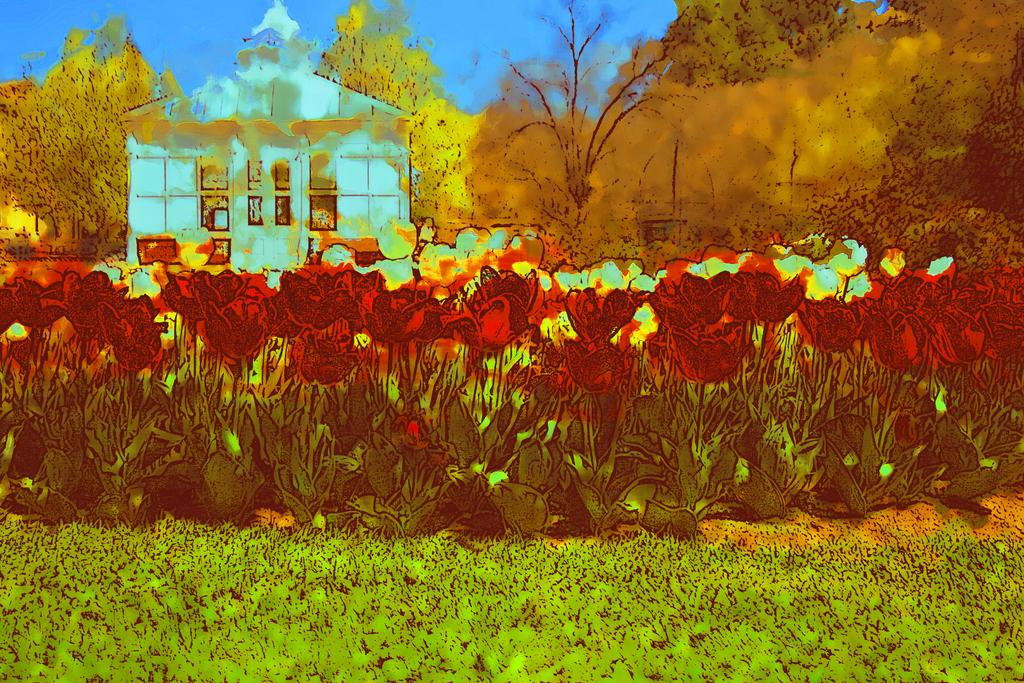What type of structure is present in the image? There is a house in the image. What features can be observed on the house? The house has a roof and windows. What type of vegetation is present in the image? There are plants with flowers and a group of trees in the image. What part of the natural environment is visible in the image? The sky is visible in the image. What is the condition of the bed in the image? There is no bed present in the image. How many bells can be heard ringing in the image? There are no bells present in the image. 